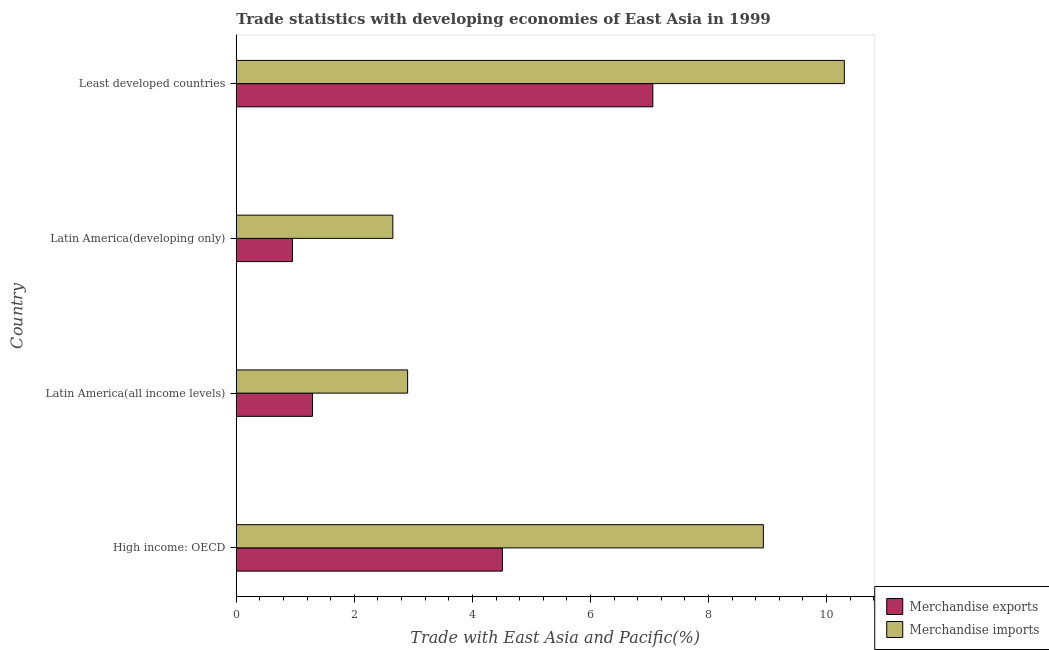Are the number of bars per tick equal to the number of legend labels?
Ensure brevity in your answer.  Yes. What is the label of the 2nd group of bars from the top?
Give a very brief answer. Latin America(developing only). In how many cases, is the number of bars for a given country not equal to the number of legend labels?
Ensure brevity in your answer.  0. What is the merchandise imports in Least developed countries?
Ensure brevity in your answer.  10.3. Across all countries, what is the maximum merchandise imports?
Your answer should be compact. 10.3. Across all countries, what is the minimum merchandise imports?
Your answer should be compact. 2.65. In which country was the merchandise exports maximum?
Keep it short and to the point. Least developed countries. In which country was the merchandise imports minimum?
Make the answer very short. Latin America(developing only). What is the total merchandise imports in the graph?
Provide a succinct answer. 24.78. What is the difference between the merchandise exports in Latin America(developing only) and that in Least developed countries?
Give a very brief answer. -6.1. What is the difference between the merchandise imports in High income: OECD and the merchandise exports in Latin America(developing only)?
Your answer should be compact. 7.98. What is the average merchandise exports per country?
Offer a terse response. 3.45. What is the difference between the merchandise imports and merchandise exports in High income: OECD?
Your answer should be very brief. 4.42. In how many countries, is the merchandise exports greater than 2.4 %?
Make the answer very short. 2. What is the ratio of the merchandise exports in Latin America(all income levels) to that in Least developed countries?
Your answer should be very brief. 0.18. Is the merchandise exports in High income: OECD less than that in Latin America(all income levels)?
Keep it short and to the point. No. Is the difference between the merchandise exports in High income: OECD and Least developed countries greater than the difference between the merchandise imports in High income: OECD and Least developed countries?
Your answer should be very brief. No. What is the difference between the highest and the second highest merchandise exports?
Your answer should be compact. 2.55. In how many countries, is the merchandise exports greater than the average merchandise exports taken over all countries?
Ensure brevity in your answer.  2. How many bars are there?
Make the answer very short. 8. How many countries are there in the graph?
Make the answer very short. 4. Does the graph contain any zero values?
Offer a very short reply. No. How many legend labels are there?
Offer a very short reply. 2. How are the legend labels stacked?
Give a very brief answer. Vertical. What is the title of the graph?
Offer a very short reply. Trade statistics with developing economies of East Asia in 1999. Does "Depositors" appear as one of the legend labels in the graph?
Keep it short and to the point. No. What is the label or title of the X-axis?
Provide a short and direct response. Trade with East Asia and Pacific(%). What is the label or title of the Y-axis?
Ensure brevity in your answer.  Country. What is the Trade with East Asia and Pacific(%) of Merchandise exports in High income: OECD?
Your answer should be very brief. 4.51. What is the Trade with East Asia and Pacific(%) of Merchandise imports in High income: OECD?
Your answer should be compact. 8.93. What is the Trade with East Asia and Pacific(%) of Merchandise exports in Latin America(all income levels)?
Give a very brief answer. 1.29. What is the Trade with East Asia and Pacific(%) in Merchandise imports in Latin America(all income levels)?
Your response must be concise. 2.9. What is the Trade with East Asia and Pacific(%) in Merchandise exports in Latin America(developing only)?
Provide a succinct answer. 0.95. What is the Trade with East Asia and Pacific(%) of Merchandise imports in Latin America(developing only)?
Your answer should be very brief. 2.65. What is the Trade with East Asia and Pacific(%) of Merchandise exports in Least developed countries?
Keep it short and to the point. 7.06. What is the Trade with East Asia and Pacific(%) in Merchandise imports in Least developed countries?
Your response must be concise. 10.3. Across all countries, what is the maximum Trade with East Asia and Pacific(%) in Merchandise exports?
Offer a very short reply. 7.06. Across all countries, what is the maximum Trade with East Asia and Pacific(%) of Merchandise imports?
Ensure brevity in your answer.  10.3. Across all countries, what is the minimum Trade with East Asia and Pacific(%) in Merchandise exports?
Make the answer very short. 0.95. Across all countries, what is the minimum Trade with East Asia and Pacific(%) of Merchandise imports?
Provide a succinct answer. 2.65. What is the total Trade with East Asia and Pacific(%) in Merchandise exports in the graph?
Offer a terse response. 13.81. What is the total Trade with East Asia and Pacific(%) in Merchandise imports in the graph?
Your answer should be very brief. 24.78. What is the difference between the Trade with East Asia and Pacific(%) of Merchandise exports in High income: OECD and that in Latin America(all income levels)?
Provide a short and direct response. 3.22. What is the difference between the Trade with East Asia and Pacific(%) in Merchandise imports in High income: OECD and that in Latin America(all income levels)?
Make the answer very short. 6.03. What is the difference between the Trade with East Asia and Pacific(%) of Merchandise exports in High income: OECD and that in Latin America(developing only)?
Offer a terse response. 3.56. What is the difference between the Trade with East Asia and Pacific(%) of Merchandise imports in High income: OECD and that in Latin America(developing only)?
Give a very brief answer. 6.28. What is the difference between the Trade with East Asia and Pacific(%) in Merchandise exports in High income: OECD and that in Least developed countries?
Your answer should be very brief. -2.55. What is the difference between the Trade with East Asia and Pacific(%) of Merchandise imports in High income: OECD and that in Least developed countries?
Ensure brevity in your answer.  -1.37. What is the difference between the Trade with East Asia and Pacific(%) of Merchandise exports in Latin America(all income levels) and that in Latin America(developing only)?
Your answer should be very brief. 0.34. What is the difference between the Trade with East Asia and Pacific(%) in Merchandise imports in Latin America(all income levels) and that in Latin America(developing only)?
Provide a short and direct response. 0.25. What is the difference between the Trade with East Asia and Pacific(%) in Merchandise exports in Latin America(all income levels) and that in Least developed countries?
Provide a short and direct response. -5.76. What is the difference between the Trade with East Asia and Pacific(%) in Merchandise imports in Latin America(all income levels) and that in Least developed countries?
Ensure brevity in your answer.  -7.4. What is the difference between the Trade with East Asia and Pacific(%) of Merchandise exports in Latin America(developing only) and that in Least developed countries?
Your answer should be compact. -6.1. What is the difference between the Trade with East Asia and Pacific(%) in Merchandise imports in Latin America(developing only) and that in Least developed countries?
Offer a very short reply. -7.65. What is the difference between the Trade with East Asia and Pacific(%) in Merchandise exports in High income: OECD and the Trade with East Asia and Pacific(%) in Merchandise imports in Latin America(all income levels)?
Ensure brevity in your answer.  1.6. What is the difference between the Trade with East Asia and Pacific(%) in Merchandise exports in High income: OECD and the Trade with East Asia and Pacific(%) in Merchandise imports in Latin America(developing only)?
Keep it short and to the point. 1.86. What is the difference between the Trade with East Asia and Pacific(%) in Merchandise exports in High income: OECD and the Trade with East Asia and Pacific(%) in Merchandise imports in Least developed countries?
Ensure brevity in your answer.  -5.79. What is the difference between the Trade with East Asia and Pacific(%) in Merchandise exports in Latin America(all income levels) and the Trade with East Asia and Pacific(%) in Merchandise imports in Latin America(developing only)?
Offer a very short reply. -1.36. What is the difference between the Trade with East Asia and Pacific(%) in Merchandise exports in Latin America(all income levels) and the Trade with East Asia and Pacific(%) in Merchandise imports in Least developed countries?
Give a very brief answer. -9.01. What is the difference between the Trade with East Asia and Pacific(%) of Merchandise exports in Latin America(developing only) and the Trade with East Asia and Pacific(%) of Merchandise imports in Least developed countries?
Your answer should be compact. -9.35. What is the average Trade with East Asia and Pacific(%) in Merchandise exports per country?
Your response must be concise. 3.45. What is the average Trade with East Asia and Pacific(%) in Merchandise imports per country?
Provide a succinct answer. 6.2. What is the difference between the Trade with East Asia and Pacific(%) in Merchandise exports and Trade with East Asia and Pacific(%) in Merchandise imports in High income: OECD?
Give a very brief answer. -4.42. What is the difference between the Trade with East Asia and Pacific(%) in Merchandise exports and Trade with East Asia and Pacific(%) in Merchandise imports in Latin America(all income levels)?
Offer a very short reply. -1.61. What is the difference between the Trade with East Asia and Pacific(%) of Merchandise exports and Trade with East Asia and Pacific(%) of Merchandise imports in Least developed countries?
Make the answer very short. -3.24. What is the ratio of the Trade with East Asia and Pacific(%) in Merchandise exports in High income: OECD to that in Latin America(all income levels)?
Provide a short and direct response. 3.49. What is the ratio of the Trade with East Asia and Pacific(%) of Merchandise imports in High income: OECD to that in Latin America(all income levels)?
Your response must be concise. 3.08. What is the ratio of the Trade with East Asia and Pacific(%) of Merchandise exports in High income: OECD to that in Latin America(developing only)?
Offer a terse response. 4.73. What is the ratio of the Trade with East Asia and Pacific(%) of Merchandise imports in High income: OECD to that in Latin America(developing only)?
Offer a very short reply. 3.37. What is the ratio of the Trade with East Asia and Pacific(%) of Merchandise exports in High income: OECD to that in Least developed countries?
Your answer should be very brief. 0.64. What is the ratio of the Trade with East Asia and Pacific(%) in Merchandise imports in High income: OECD to that in Least developed countries?
Give a very brief answer. 0.87. What is the ratio of the Trade with East Asia and Pacific(%) in Merchandise exports in Latin America(all income levels) to that in Latin America(developing only)?
Your answer should be compact. 1.36. What is the ratio of the Trade with East Asia and Pacific(%) of Merchandise imports in Latin America(all income levels) to that in Latin America(developing only)?
Make the answer very short. 1.09. What is the ratio of the Trade with East Asia and Pacific(%) of Merchandise exports in Latin America(all income levels) to that in Least developed countries?
Provide a succinct answer. 0.18. What is the ratio of the Trade with East Asia and Pacific(%) in Merchandise imports in Latin America(all income levels) to that in Least developed countries?
Offer a very short reply. 0.28. What is the ratio of the Trade with East Asia and Pacific(%) in Merchandise exports in Latin America(developing only) to that in Least developed countries?
Your response must be concise. 0.14. What is the ratio of the Trade with East Asia and Pacific(%) of Merchandise imports in Latin America(developing only) to that in Least developed countries?
Your response must be concise. 0.26. What is the difference between the highest and the second highest Trade with East Asia and Pacific(%) in Merchandise exports?
Give a very brief answer. 2.55. What is the difference between the highest and the second highest Trade with East Asia and Pacific(%) in Merchandise imports?
Your response must be concise. 1.37. What is the difference between the highest and the lowest Trade with East Asia and Pacific(%) in Merchandise exports?
Give a very brief answer. 6.1. What is the difference between the highest and the lowest Trade with East Asia and Pacific(%) of Merchandise imports?
Your answer should be compact. 7.65. 